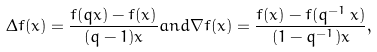<formula> <loc_0><loc_0><loc_500><loc_500>\Delta f ( x ) = \frac { f ( q x ) - f ( x ) } { ( q - 1 ) x } a n d \nabla f ( x ) = \frac { f ( x ) - f ( q ^ { - 1 } \, x ) } { ( 1 - q ^ { - 1 } ) x } ,</formula> 